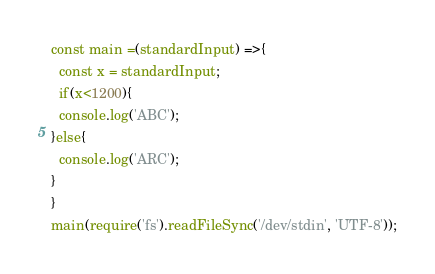<code> <loc_0><loc_0><loc_500><loc_500><_JavaScript_>
const main =(standardInput) =>{
  const x = standardInput;
  if(x<1200){
  console.log('ABC');
}else{
  console.log('ARC');
}
}
main(require('fs').readFileSync('/dev/stdin', 'UTF-8'));</code> 